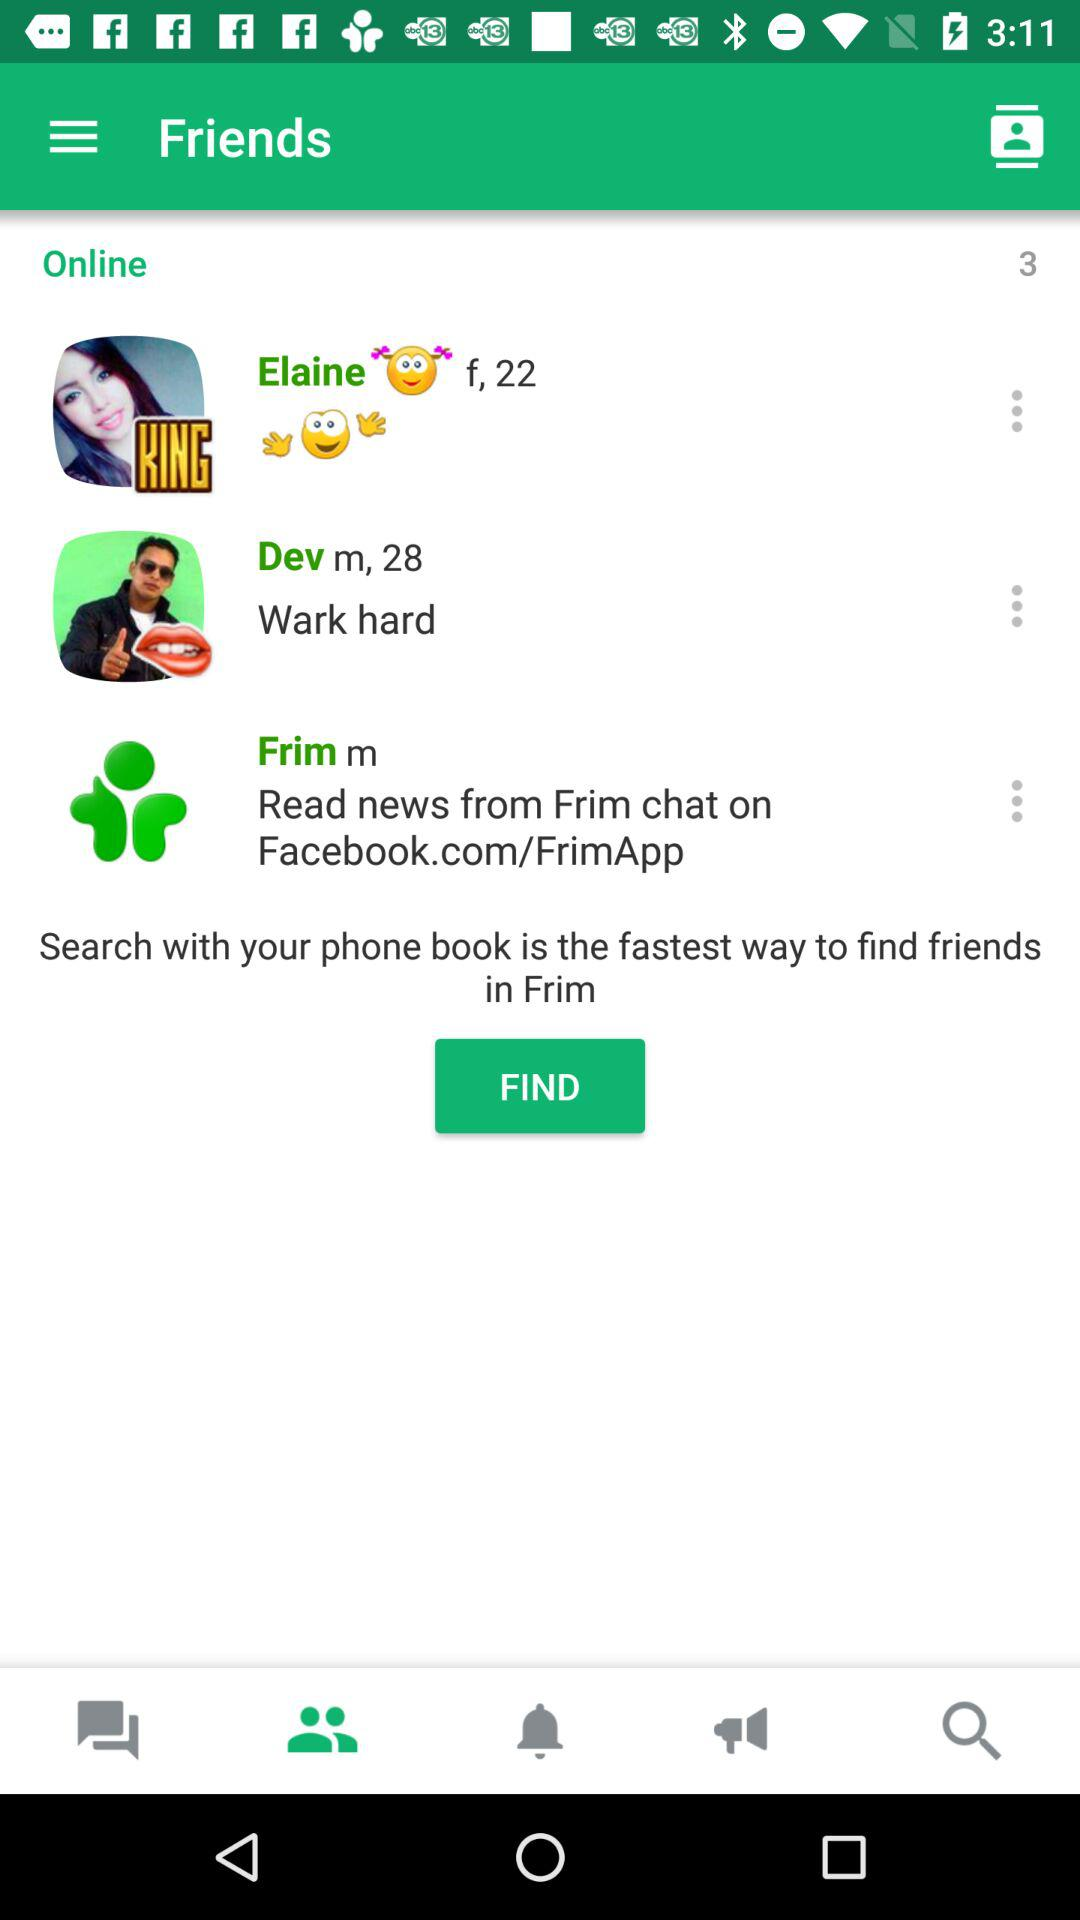What is the age of Dev? Dev is 28 years old. 